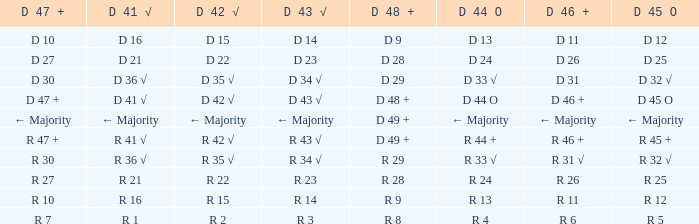What is the value of D 46 +, when the value of D 42 √ is r 2? R 6. 